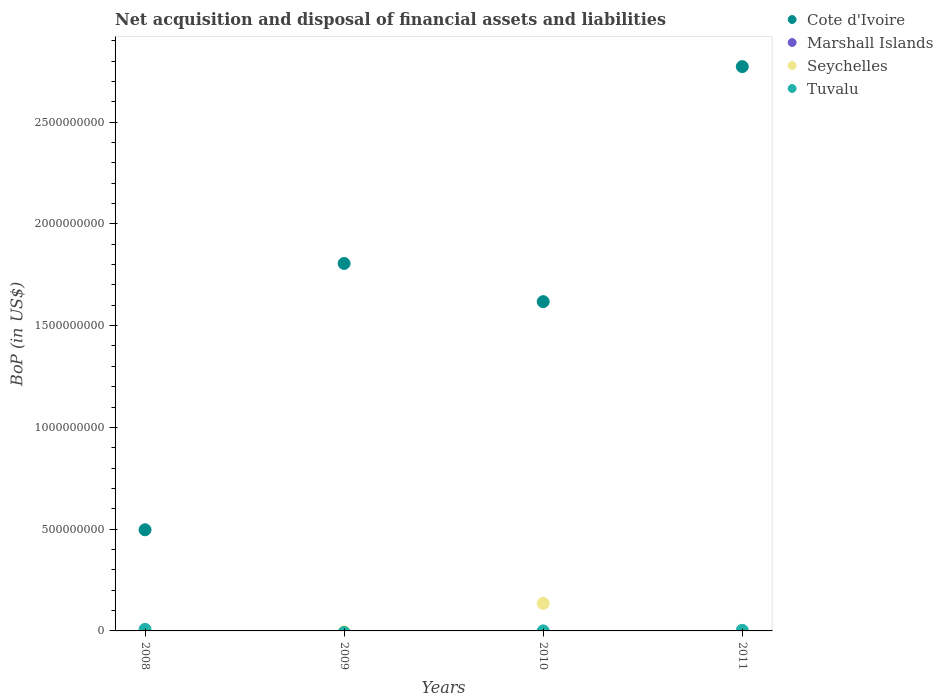How many different coloured dotlines are there?
Your response must be concise. 3. Is the number of dotlines equal to the number of legend labels?
Offer a very short reply. No. What is the Balance of Payments in Tuvalu in 2008?
Make the answer very short. 7.56e+06. Across all years, what is the maximum Balance of Payments in Tuvalu?
Make the answer very short. 7.56e+06. Across all years, what is the minimum Balance of Payments in Seychelles?
Your answer should be compact. 0. In which year was the Balance of Payments in Cote d'Ivoire maximum?
Offer a very short reply. 2011. What is the total Balance of Payments in Marshall Islands in the graph?
Your response must be concise. 0. What is the difference between the Balance of Payments in Cote d'Ivoire in 2008 and that in 2010?
Your response must be concise. -1.12e+09. What is the difference between the Balance of Payments in Marshall Islands in 2011 and the Balance of Payments in Tuvalu in 2010?
Offer a terse response. -2.04e+05. What is the average Balance of Payments in Seychelles per year?
Keep it short and to the point. 3.39e+07. In the year 2010, what is the difference between the Balance of Payments in Seychelles and Balance of Payments in Cote d'Ivoire?
Your answer should be compact. -1.48e+09. In how many years, is the Balance of Payments in Marshall Islands greater than 1300000000 US$?
Provide a succinct answer. 0. What is the ratio of the Balance of Payments in Cote d'Ivoire in 2008 to that in 2009?
Your answer should be very brief. 0.28. What is the difference between the highest and the second highest Balance of Payments in Tuvalu?
Your answer should be compact. 4.60e+06. What is the difference between the highest and the lowest Balance of Payments in Cote d'Ivoire?
Provide a succinct answer. 2.28e+09. In how many years, is the Balance of Payments in Marshall Islands greater than the average Balance of Payments in Marshall Islands taken over all years?
Keep it short and to the point. 0. Is the sum of the Balance of Payments in Tuvalu in 2008 and 2010 greater than the maximum Balance of Payments in Seychelles across all years?
Provide a short and direct response. No. Is it the case that in every year, the sum of the Balance of Payments in Tuvalu and Balance of Payments in Cote d'Ivoire  is greater than the sum of Balance of Payments in Marshall Islands and Balance of Payments in Seychelles?
Provide a succinct answer. No. Does the Balance of Payments in Seychelles monotonically increase over the years?
Give a very brief answer. No. Is the Balance of Payments in Seychelles strictly greater than the Balance of Payments in Cote d'Ivoire over the years?
Keep it short and to the point. No. Is the Balance of Payments in Tuvalu strictly less than the Balance of Payments in Cote d'Ivoire over the years?
Provide a short and direct response. Yes. How many dotlines are there?
Keep it short and to the point. 3. How many years are there in the graph?
Make the answer very short. 4. What is the difference between two consecutive major ticks on the Y-axis?
Make the answer very short. 5.00e+08. Does the graph contain any zero values?
Offer a terse response. Yes. Does the graph contain grids?
Keep it short and to the point. No. Where does the legend appear in the graph?
Ensure brevity in your answer.  Top right. How many legend labels are there?
Make the answer very short. 4. How are the legend labels stacked?
Provide a short and direct response. Vertical. What is the title of the graph?
Ensure brevity in your answer.  Net acquisition and disposal of financial assets and liabilities. What is the label or title of the Y-axis?
Your answer should be compact. BoP (in US$). What is the BoP (in US$) in Cote d'Ivoire in 2008?
Offer a very short reply. 4.97e+08. What is the BoP (in US$) of Marshall Islands in 2008?
Provide a succinct answer. 0. What is the BoP (in US$) in Seychelles in 2008?
Offer a terse response. 0. What is the BoP (in US$) in Tuvalu in 2008?
Provide a succinct answer. 7.56e+06. What is the BoP (in US$) of Cote d'Ivoire in 2009?
Your response must be concise. 1.81e+09. What is the BoP (in US$) of Marshall Islands in 2009?
Your response must be concise. 0. What is the BoP (in US$) in Cote d'Ivoire in 2010?
Provide a short and direct response. 1.62e+09. What is the BoP (in US$) in Seychelles in 2010?
Make the answer very short. 1.36e+08. What is the BoP (in US$) in Tuvalu in 2010?
Provide a succinct answer. 2.04e+05. What is the BoP (in US$) of Cote d'Ivoire in 2011?
Give a very brief answer. 2.77e+09. What is the BoP (in US$) of Marshall Islands in 2011?
Your answer should be compact. 0. What is the BoP (in US$) of Seychelles in 2011?
Your answer should be compact. 0. What is the BoP (in US$) of Tuvalu in 2011?
Offer a terse response. 2.96e+06. Across all years, what is the maximum BoP (in US$) in Cote d'Ivoire?
Make the answer very short. 2.77e+09. Across all years, what is the maximum BoP (in US$) in Seychelles?
Offer a very short reply. 1.36e+08. Across all years, what is the maximum BoP (in US$) in Tuvalu?
Provide a short and direct response. 7.56e+06. Across all years, what is the minimum BoP (in US$) of Cote d'Ivoire?
Your answer should be compact. 4.97e+08. Across all years, what is the minimum BoP (in US$) of Tuvalu?
Your response must be concise. 0. What is the total BoP (in US$) of Cote d'Ivoire in the graph?
Keep it short and to the point. 6.69e+09. What is the total BoP (in US$) in Seychelles in the graph?
Offer a terse response. 1.36e+08. What is the total BoP (in US$) in Tuvalu in the graph?
Your answer should be very brief. 1.07e+07. What is the difference between the BoP (in US$) of Cote d'Ivoire in 2008 and that in 2009?
Ensure brevity in your answer.  -1.31e+09. What is the difference between the BoP (in US$) of Cote d'Ivoire in 2008 and that in 2010?
Make the answer very short. -1.12e+09. What is the difference between the BoP (in US$) in Tuvalu in 2008 and that in 2010?
Provide a succinct answer. 7.36e+06. What is the difference between the BoP (in US$) of Cote d'Ivoire in 2008 and that in 2011?
Your answer should be compact. -2.28e+09. What is the difference between the BoP (in US$) of Tuvalu in 2008 and that in 2011?
Provide a short and direct response. 4.60e+06. What is the difference between the BoP (in US$) of Cote d'Ivoire in 2009 and that in 2010?
Offer a very short reply. 1.88e+08. What is the difference between the BoP (in US$) in Cote d'Ivoire in 2009 and that in 2011?
Provide a short and direct response. -9.67e+08. What is the difference between the BoP (in US$) in Cote d'Ivoire in 2010 and that in 2011?
Ensure brevity in your answer.  -1.15e+09. What is the difference between the BoP (in US$) in Tuvalu in 2010 and that in 2011?
Your answer should be very brief. -2.76e+06. What is the difference between the BoP (in US$) of Cote d'Ivoire in 2008 and the BoP (in US$) of Seychelles in 2010?
Your response must be concise. 3.61e+08. What is the difference between the BoP (in US$) in Cote d'Ivoire in 2008 and the BoP (in US$) in Tuvalu in 2010?
Your response must be concise. 4.97e+08. What is the difference between the BoP (in US$) of Cote d'Ivoire in 2008 and the BoP (in US$) of Tuvalu in 2011?
Offer a very short reply. 4.94e+08. What is the difference between the BoP (in US$) of Cote d'Ivoire in 2009 and the BoP (in US$) of Seychelles in 2010?
Your response must be concise. 1.67e+09. What is the difference between the BoP (in US$) of Cote d'Ivoire in 2009 and the BoP (in US$) of Tuvalu in 2010?
Provide a succinct answer. 1.81e+09. What is the difference between the BoP (in US$) in Cote d'Ivoire in 2009 and the BoP (in US$) in Tuvalu in 2011?
Your answer should be compact. 1.80e+09. What is the difference between the BoP (in US$) in Cote d'Ivoire in 2010 and the BoP (in US$) in Tuvalu in 2011?
Offer a very short reply. 1.61e+09. What is the difference between the BoP (in US$) of Seychelles in 2010 and the BoP (in US$) of Tuvalu in 2011?
Offer a very short reply. 1.33e+08. What is the average BoP (in US$) of Cote d'Ivoire per year?
Your answer should be compact. 1.67e+09. What is the average BoP (in US$) of Marshall Islands per year?
Provide a short and direct response. 0. What is the average BoP (in US$) in Seychelles per year?
Offer a very short reply. 3.39e+07. What is the average BoP (in US$) in Tuvalu per year?
Offer a very short reply. 2.68e+06. In the year 2008, what is the difference between the BoP (in US$) in Cote d'Ivoire and BoP (in US$) in Tuvalu?
Provide a succinct answer. 4.89e+08. In the year 2010, what is the difference between the BoP (in US$) of Cote d'Ivoire and BoP (in US$) of Seychelles?
Offer a very short reply. 1.48e+09. In the year 2010, what is the difference between the BoP (in US$) of Cote d'Ivoire and BoP (in US$) of Tuvalu?
Your answer should be compact. 1.62e+09. In the year 2010, what is the difference between the BoP (in US$) in Seychelles and BoP (in US$) in Tuvalu?
Give a very brief answer. 1.35e+08. In the year 2011, what is the difference between the BoP (in US$) in Cote d'Ivoire and BoP (in US$) in Tuvalu?
Keep it short and to the point. 2.77e+09. What is the ratio of the BoP (in US$) of Cote d'Ivoire in 2008 to that in 2009?
Ensure brevity in your answer.  0.28. What is the ratio of the BoP (in US$) in Cote d'Ivoire in 2008 to that in 2010?
Keep it short and to the point. 0.31. What is the ratio of the BoP (in US$) in Tuvalu in 2008 to that in 2010?
Your answer should be very brief. 37.07. What is the ratio of the BoP (in US$) in Cote d'Ivoire in 2008 to that in 2011?
Provide a succinct answer. 0.18. What is the ratio of the BoP (in US$) in Tuvalu in 2008 to that in 2011?
Give a very brief answer. 2.55. What is the ratio of the BoP (in US$) in Cote d'Ivoire in 2009 to that in 2010?
Ensure brevity in your answer.  1.12. What is the ratio of the BoP (in US$) of Cote d'Ivoire in 2009 to that in 2011?
Make the answer very short. 0.65. What is the ratio of the BoP (in US$) in Cote d'Ivoire in 2010 to that in 2011?
Your response must be concise. 0.58. What is the ratio of the BoP (in US$) in Tuvalu in 2010 to that in 2011?
Your answer should be compact. 0.07. What is the difference between the highest and the second highest BoP (in US$) of Cote d'Ivoire?
Your response must be concise. 9.67e+08. What is the difference between the highest and the second highest BoP (in US$) of Tuvalu?
Give a very brief answer. 4.60e+06. What is the difference between the highest and the lowest BoP (in US$) in Cote d'Ivoire?
Offer a terse response. 2.28e+09. What is the difference between the highest and the lowest BoP (in US$) in Seychelles?
Your answer should be compact. 1.36e+08. What is the difference between the highest and the lowest BoP (in US$) of Tuvalu?
Give a very brief answer. 7.56e+06. 